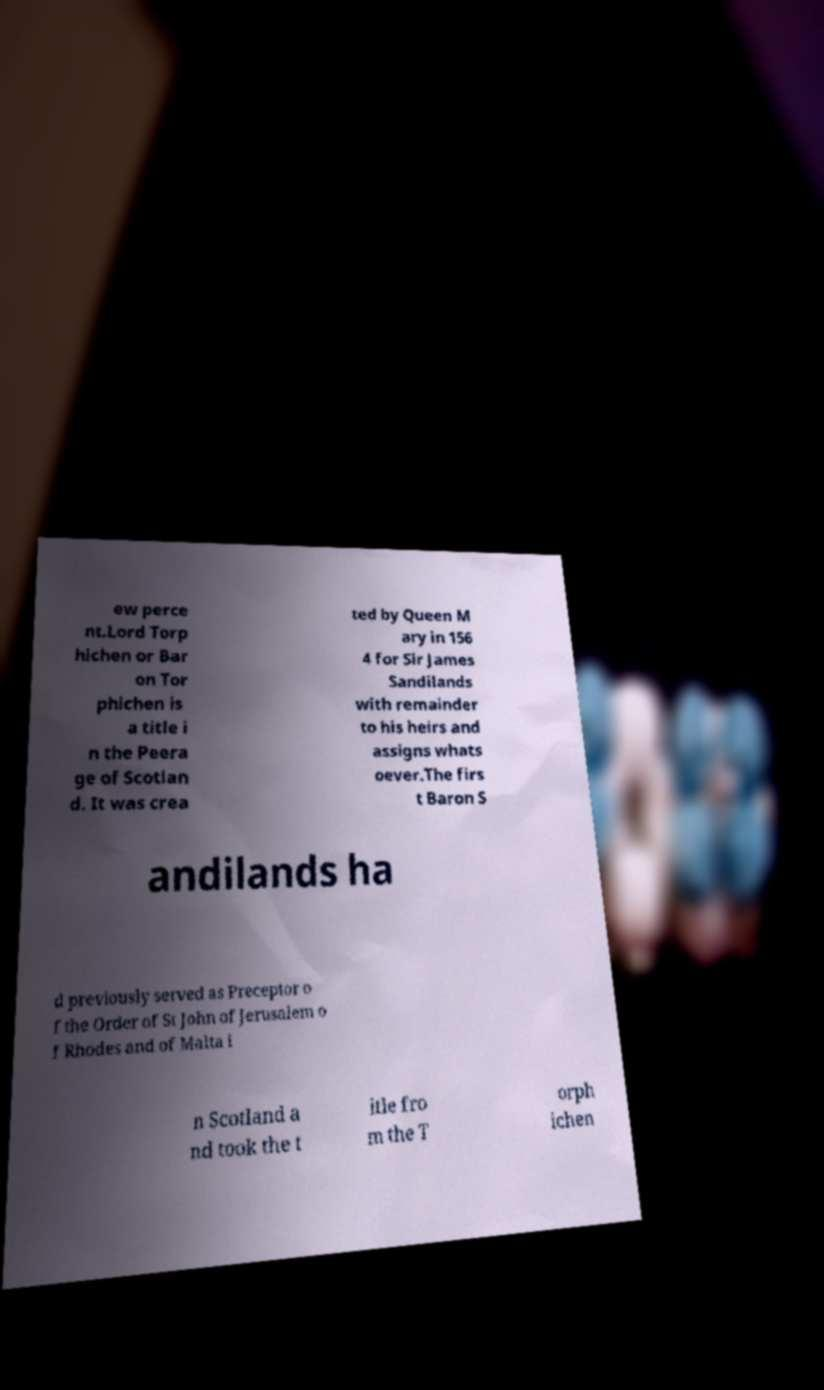I need the written content from this picture converted into text. Can you do that? ew perce nt.Lord Torp hichen or Bar on Tor phichen is a title i n the Peera ge of Scotlan d. It was crea ted by Queen M ary in 156 4 for Sir James Sandilands with remainder to his heirs and assigns whats oever.The firs t Baron S andilands ha d previously served as Preceptor o f the Order of St John of Jerusalem o f Rhodes and of Malta i n Scotland a nd took the t itle fro m the T orph ichen 